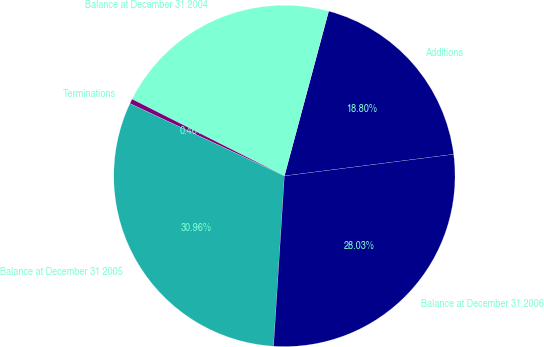<chart> <loc_0><loc_0><loc_500><loc_500><pie_chart><fcel>Additions<fcel>Balance at December 31 2004<fcel>Terminations<fcel>Balance at December 31 2005<fcel>Balance at December 31 2006<nl><fcel>18.8%<fcel>21.74%<fcel>0.46%<fcel>30.96%<fcel>28.03%<nl></chart> 